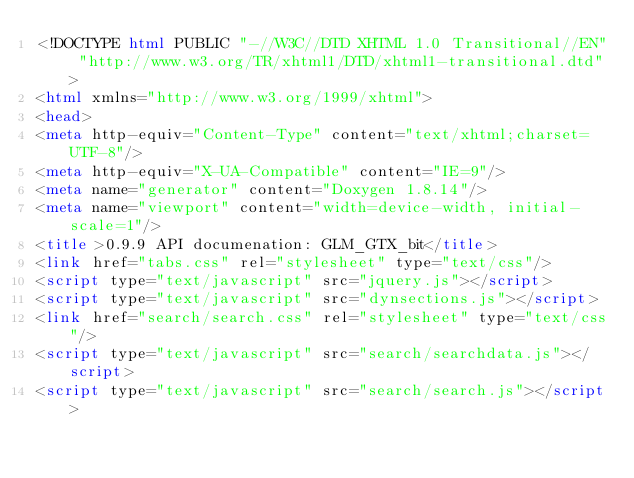<code> <loc_0><loc_0><loc_500><loc_500><_HTML_><!DOCTYPE html PUBLIC "-//W3C//DTD XHTML 1.0 Transitional//EN" "http://www.w3.org/TR/xhtml1/DTD/xhtml1-transitional.dtd">
<html xmlns="http://www.w3.org/1999/xhtml">
<head>
<meta http-equiv="Content-Type" content="text/xhtml;charset=UTF-8"/>
<meta http-equiv="X-UA-Compatible" content="IE=9"/>
<meta name="generator" content="Doxygen 1.8.14"/>
<meta name="viewport" content="width=device-width, initial-scale=1"/>
<title>0.9.9 API documenation: GLM_GTX_bit</title>
<link href="tabs.css" rel="stylesheet" type="text/css"/>
<script type="text/javascript" src="jquery.js"></script>
<script type="text/javascript" src="dynsections.js"></script>
<link href="search/search.css" rel="stylesheet" type="text/css"/>
<script type="text/javascript" src="search/searchdata.js"></script>
<script type="text/javascript" src="search/search.js"></script></code> 